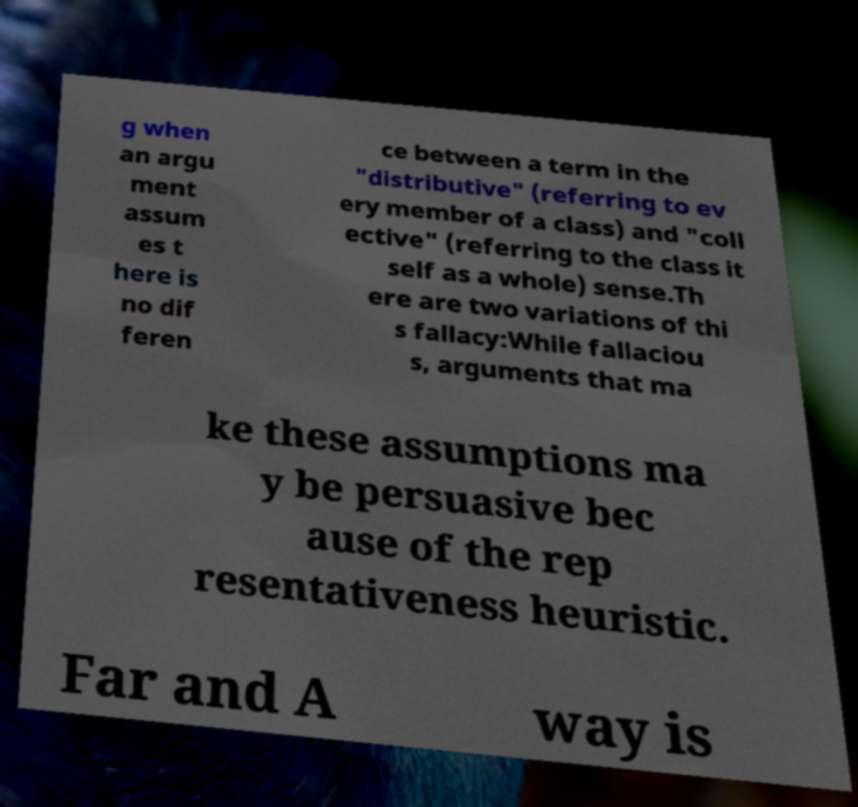Can you accurately transcribe the text from the provided image for me? g when an argu ment assum es t here is no dif feren ce between a term in the "distributive" (referring to ev ery member of a class) and "coll ective" (referring to the class it self as a whole) sense.Th ere are two variations of thi s fallacy:While fallaciou s, arguments that ma ke these assumptions ma y be persuasive bec ause of the rep resentativeness heuristic. Far and A way is 